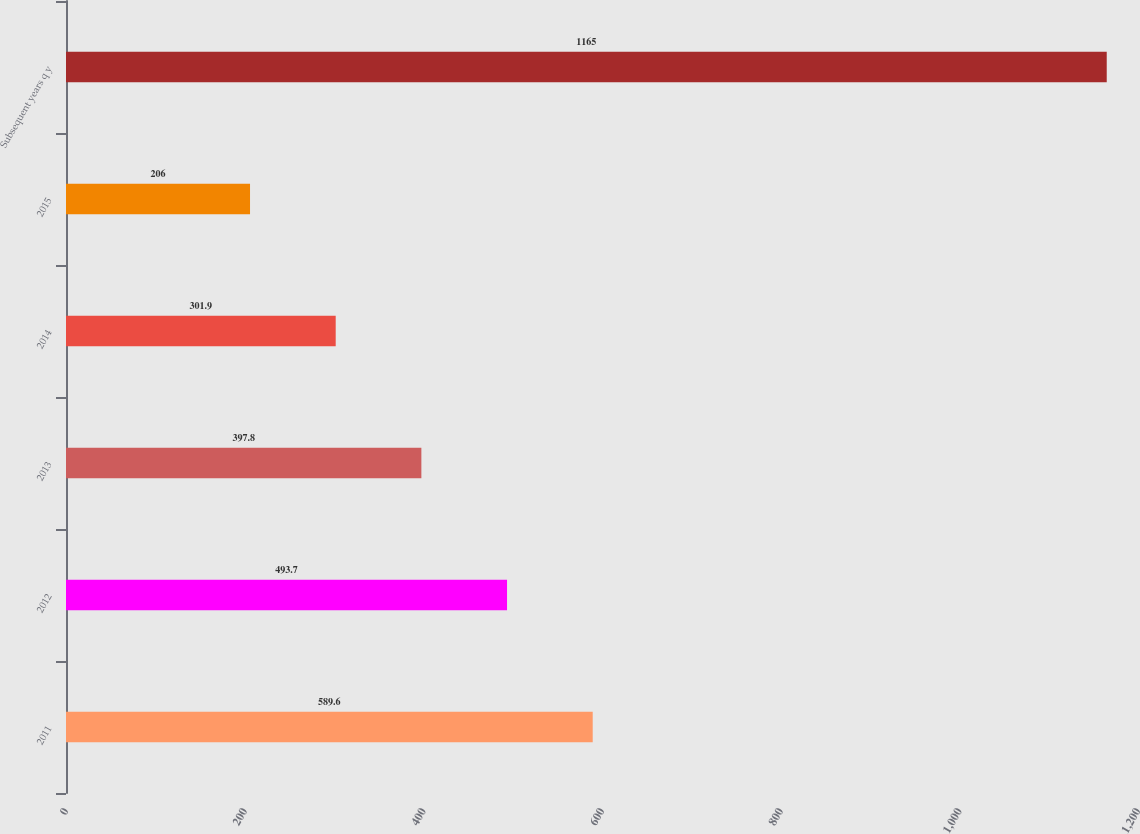<chart> <loc_0><loc_0><loc_500><loc_500><bar_chart><fcel>2011<fcel>2012<fcel>2013<fcel>2014<fcel>2015<fcel>Subsequent years q y<nl><fcel>589.6<fcel>493.7<fcel>397.8<fcel>301.9<fcel>206<fcel>1165<nl></chart> 